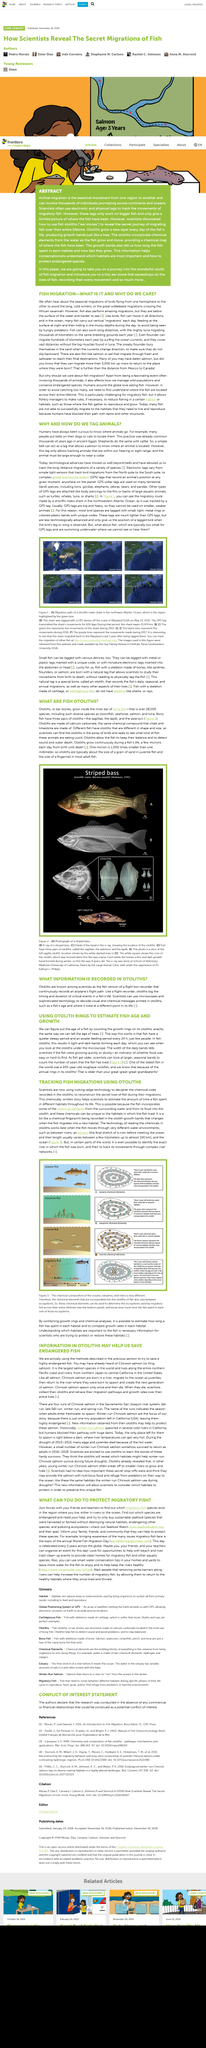Give some essential details in this illustration. Ear stones, also known as Otoliths, grow inside the inner ears of bony fish. Otoliths are made of calcium carbonate, the same chemical compound that chalk and limestone are made of. The GPS data revealed that the shark traveled a total distance of 21,974 kilometers over the 626 days of monitoring. There are various species of bony fish, including clownfish, seahorse, salmon, and tuna. The chinook salmon, a fish with an otolith, inhabits both rivers and oceans throughout its lifetime. 